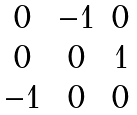Convert formula to latex. <formula><loc_0><loc_0><loc_500><loc_500>\begin{matrix} 0 & - 1 & 0 \\ 0 & 0 & 1 \\ - 1 & 0 & 0 \end{matrix}</formula> 